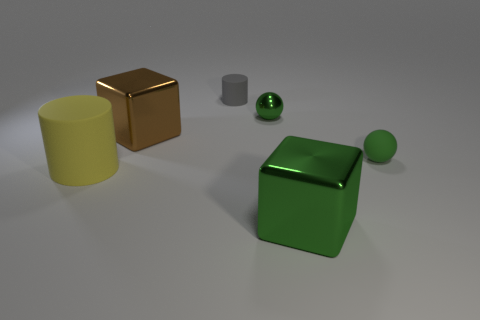The cylinder in front of the gray matte thing that is left of the tiny rubber thing that is to the right of the big green block is what color?
Your answer should be very brief. Yellow. Are any tiny green shiny objects visible?
Offer a very short reply. Yes. How many other things are there of the same size as the brown cube?
Give a very brief answer. 2. There is a big rubber object; is it the same color as the tiny ball that is to the left of the matte sphere?
Ensure brevity in your answer.  No. What number of things are either big yellow rubber cylinders or tiny spheres?
Your response must be concise. 3. Is there any other thing of the same color as the big cylinder?
Provide a succinct answer. No. Does the tiny cylinder have the same material as the small green ball left of the green rubber thing?
Offer a very short reply. No. What is the shape of the small green thing to the right of the metallic cube that is right of the small gray cylinder?
Make the answer very short. Sphere. The metal thing that is both to the right of the tiny cylinder and in front of the small green shiny object has what shape?
Provide a short and direct response. Cube. How many objects are either blue matte cylinders or metallic blocks behind the big green shiny thing?
Your response must be concise. 1. 